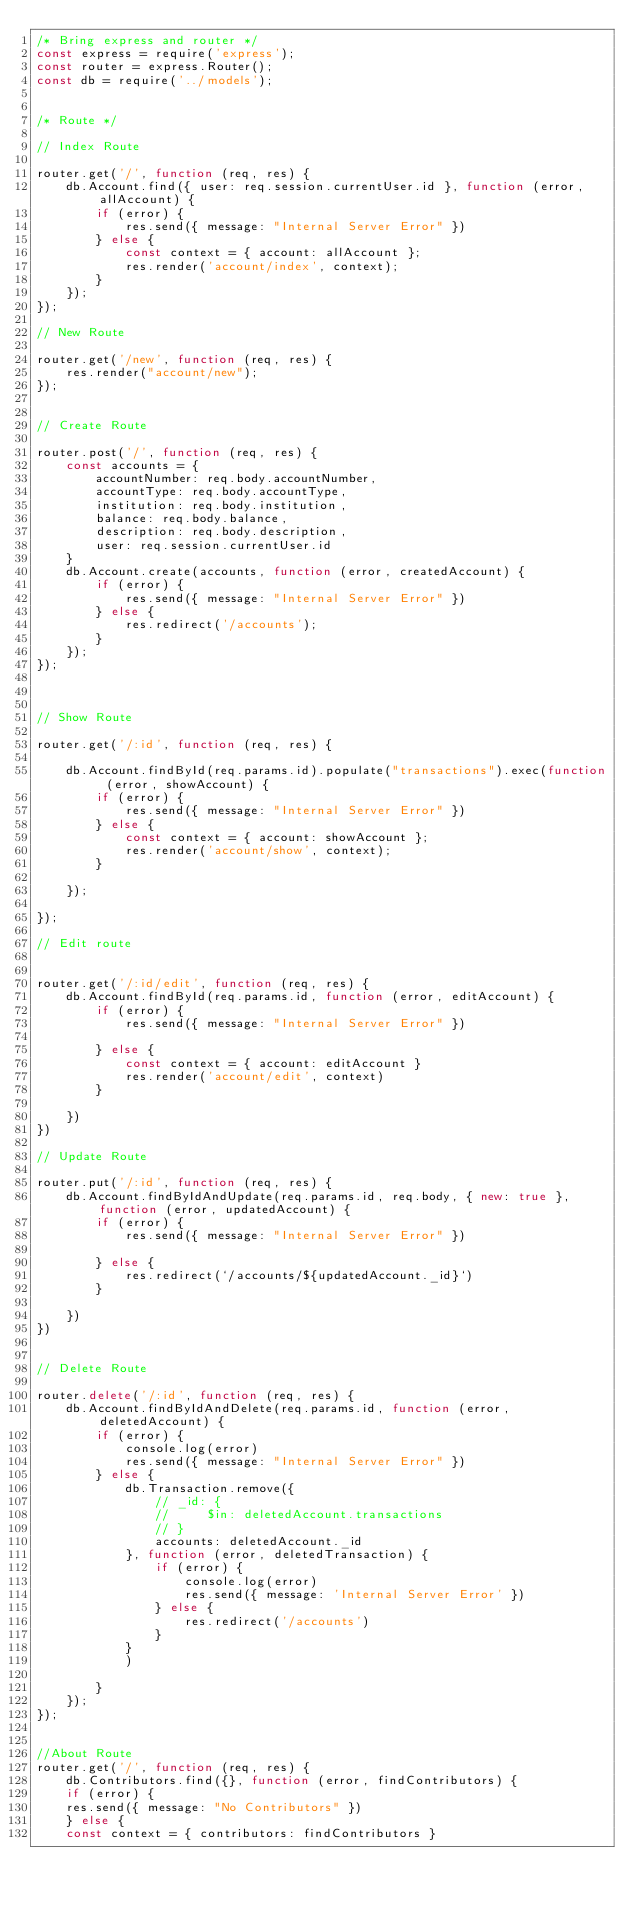<code> <loc_0><loc_0><loc_500><loc_500><_JavaScript_>/* Bring express and router */
const express = require('express');
const router = express.Router();
const db = require('../models');


/* Route */

// Index Route

router.get('/', function (req, res) {
    db.Account.find({ user: req.session.currentUser.id }, function (error, allAccount) {
        if (error) {
            res.send({ message: "Internal Server Error" })
        } else {
            const context = { account: allAccount };
            res.render('account/index', context);
        }
    });
});

// New Route

router.get('/new', function (req, res) {
    res.render("account/new");
});


// Create Route

router.post('/', function (req, res) {
    const accounts = {
        accountNumber: req.body.accountNumber,
        accountType: req.body.accountType,
        institution: req.body.institution,
        balance: req.body.balance,
        description: req.body.description,
        user: req.session.currentUser.id
    }
    db.Account.create(accounts, function (error, createdAccount) {
        if (error) {
            res.send({ message: "Internal Server Error" })
        } else {
            res.redirect('/accounts');
        }
    });
});



// Show Route

router.get('/:id', function (req, res) {

    db.Account.findById(req.params.id).populate("transactions").exec(function (error, showAccount) {
        if (error) {
            res.send({ message: "Internal Server Error" })
        } else {
            const context = { account: showAccount };
            res.render('account/show', context);
        }

    });

});

// Edit route


router.get('/:id/edit', function (req, res) {
    db.Account.findById(req.params.id, function (error, editAccount) {
        if (error) {
            res.send({ message: "Internal Server Error" })

        } else {
            const context = { account: editAccount }
            res.render('account/edit', context)
        }

    })
})

// Update Route

router.put('/:id', function (req, res) {
    db.Account.findByIdAndUpdate(req.params.id, req.body, { new: true }, function (error, updatedAccount) {
        if (error) {
            res.send({ message: "Internal Server Error" })

        } else {
            res.redirect(`/accounts/${updatedAccount._id}`)
        }

    })
})


// Delete Route

router.delete('/:id', function (req, res) {
    db.Account.findByIdAndDelete(req.params.id, function (error, deletedAccount) {
        if (error) {
            console.log(error)
            res.send({ message: "Internal Server Error" })
        } else {
            db.Transaction.remove({
                // _id: {
                //     $in: deletedAccount.transactions
                // }
                accounts: deletedAccount._id
            }, function (error, deletedTransaction) {
                if (error) {
                    console.log(error)
                    res.send({ message: 'Internal Server Error' })
                } else {
                    res.redirect('/accounts')
                }
            }
            )

        }
    });
});


//About Route
router.get('/', function (req, res) {
    db.Contributors.find({}, function (error, findContributors) {
    if (error) {
    res.send({ message: "No Contributors" })
    } else {
    const context = { contributors: findContributors }</code> 